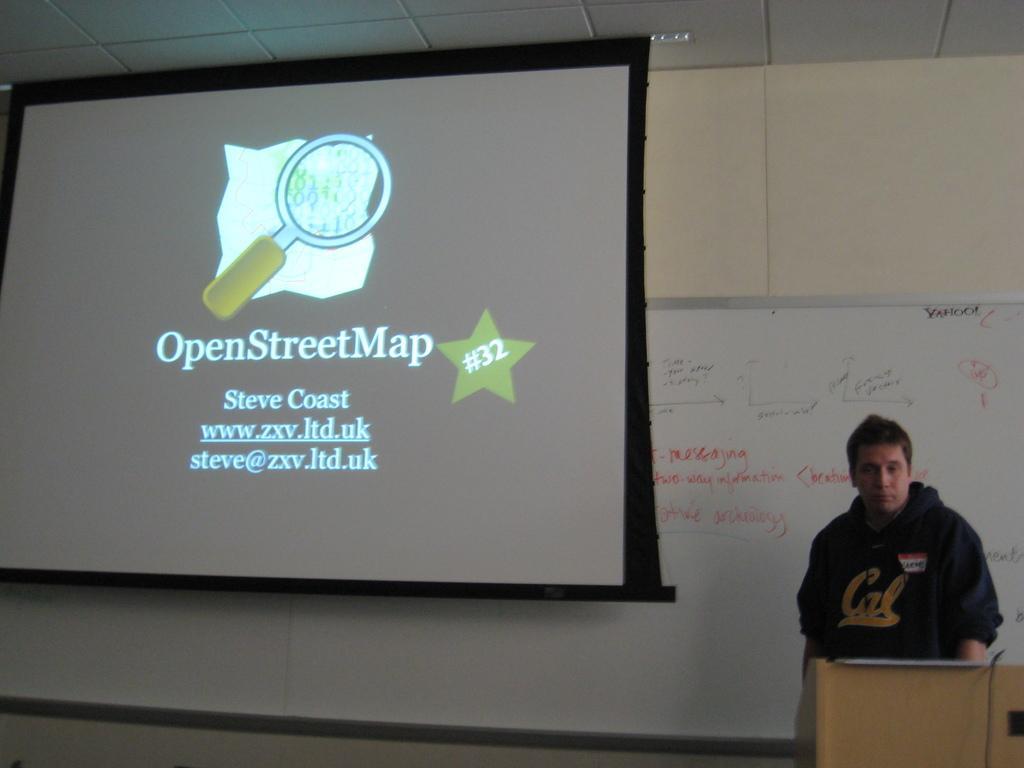Describe this image in one or two sentences. In the picture we can see a wall on it, we can see a screen with some information and beside we can see a white color board with some information on it and near to it, we can see a man standing near the desk he is with a black color hoodie, and to the ceiling we can see a light. 